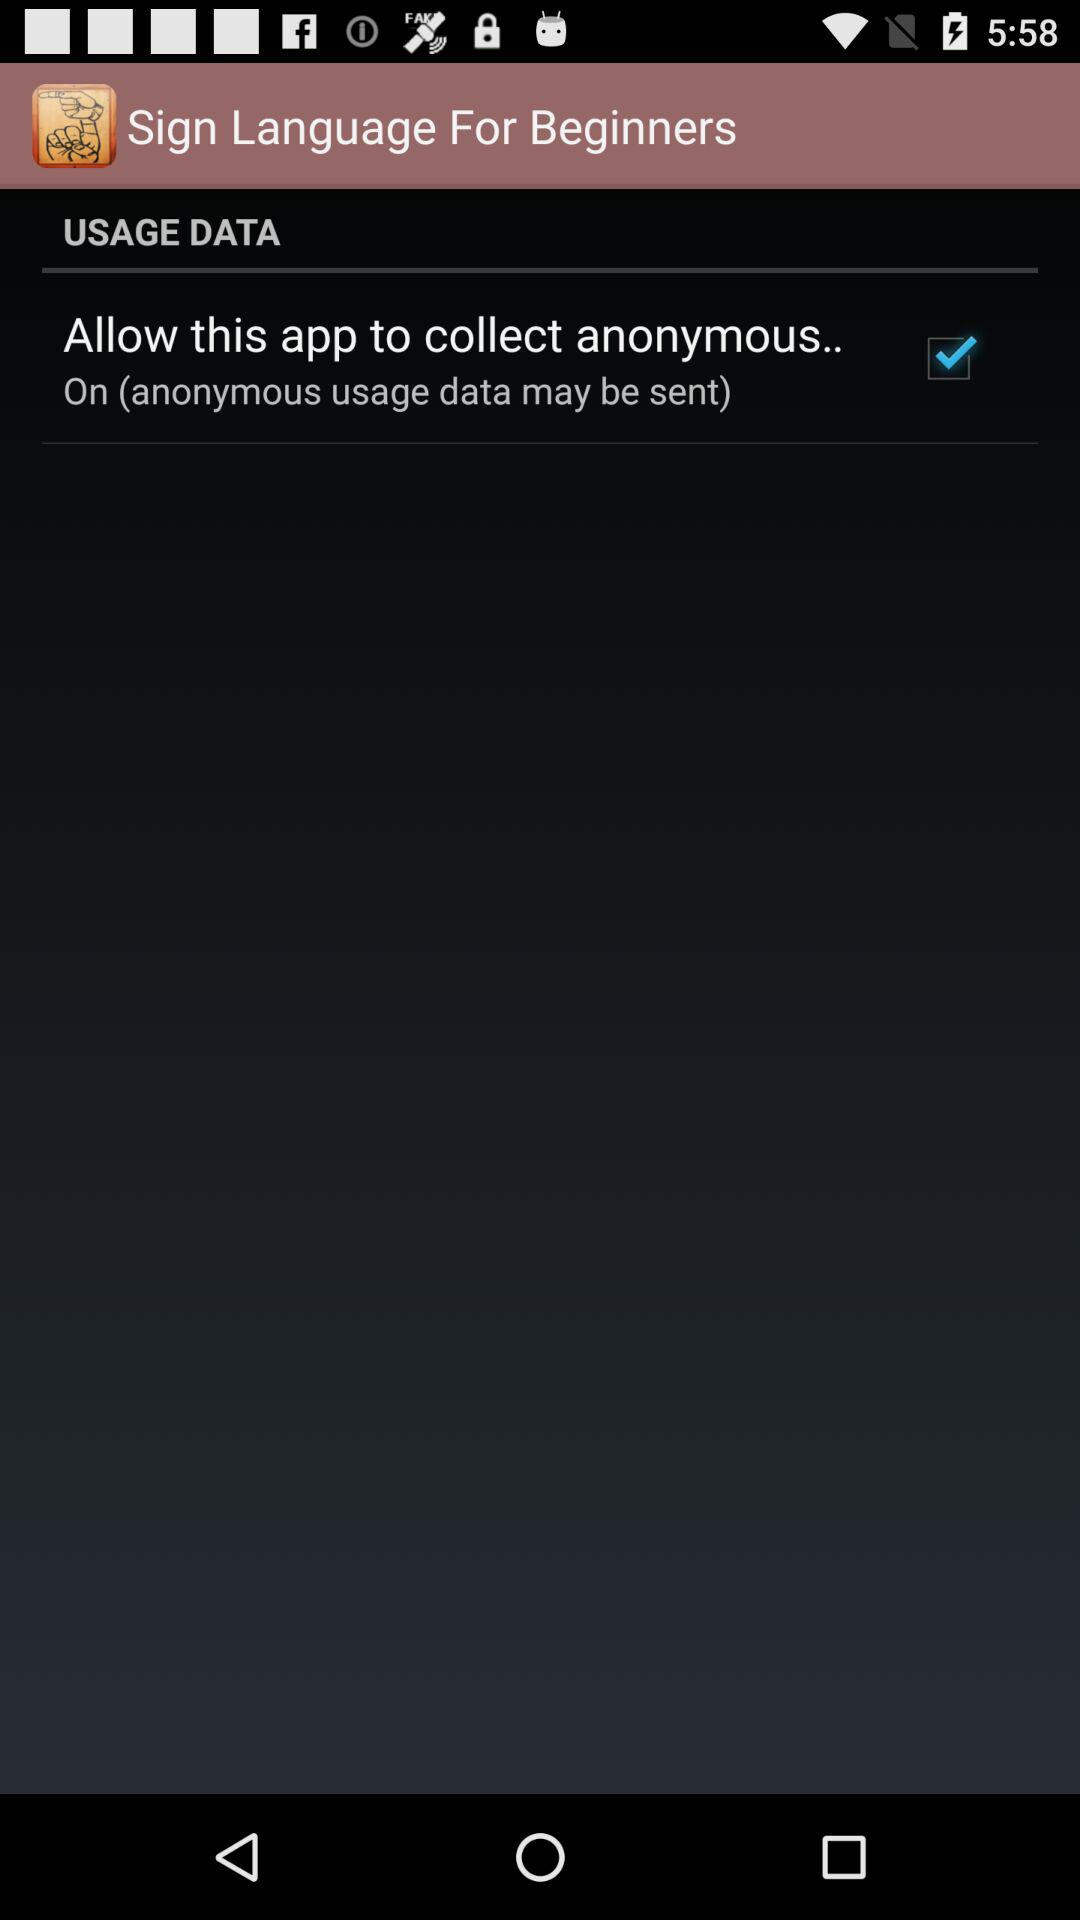What is the status of "Allow this app to collect anonymous.."? The status is "on". 